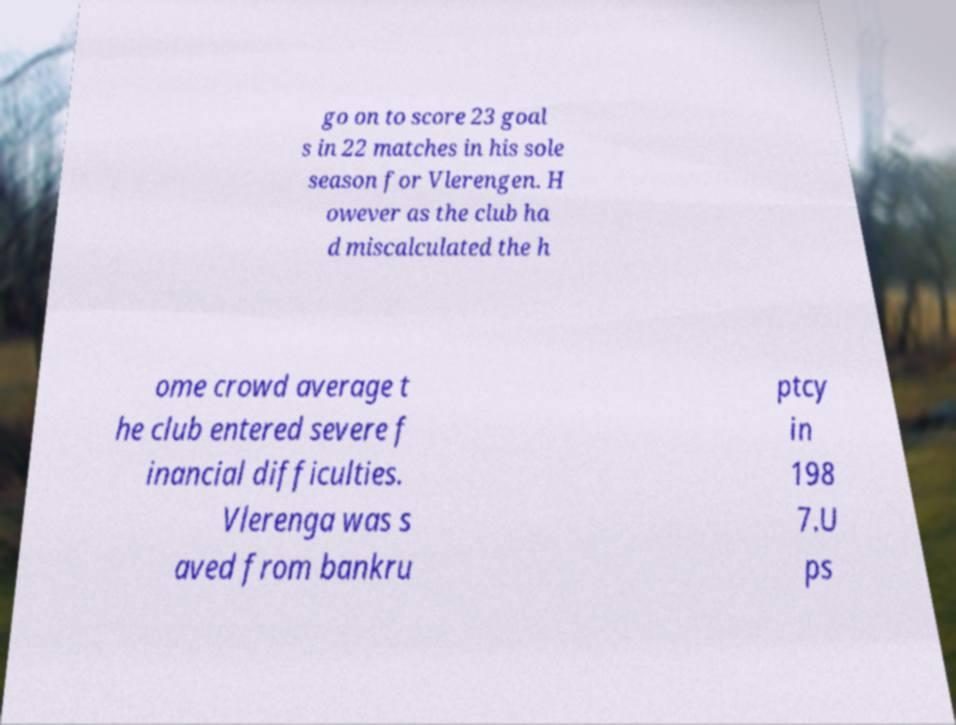Could you extract and type out the text from this image? go on to score 23 goal s in 22 matches in his sole season for Vlerengen. H owever as the club ha d miscalculated the h ome crowd average t he club entered severe f inancial difficulties. Vlerenga was s aved from bankru ptcy in 198 7.U ps 